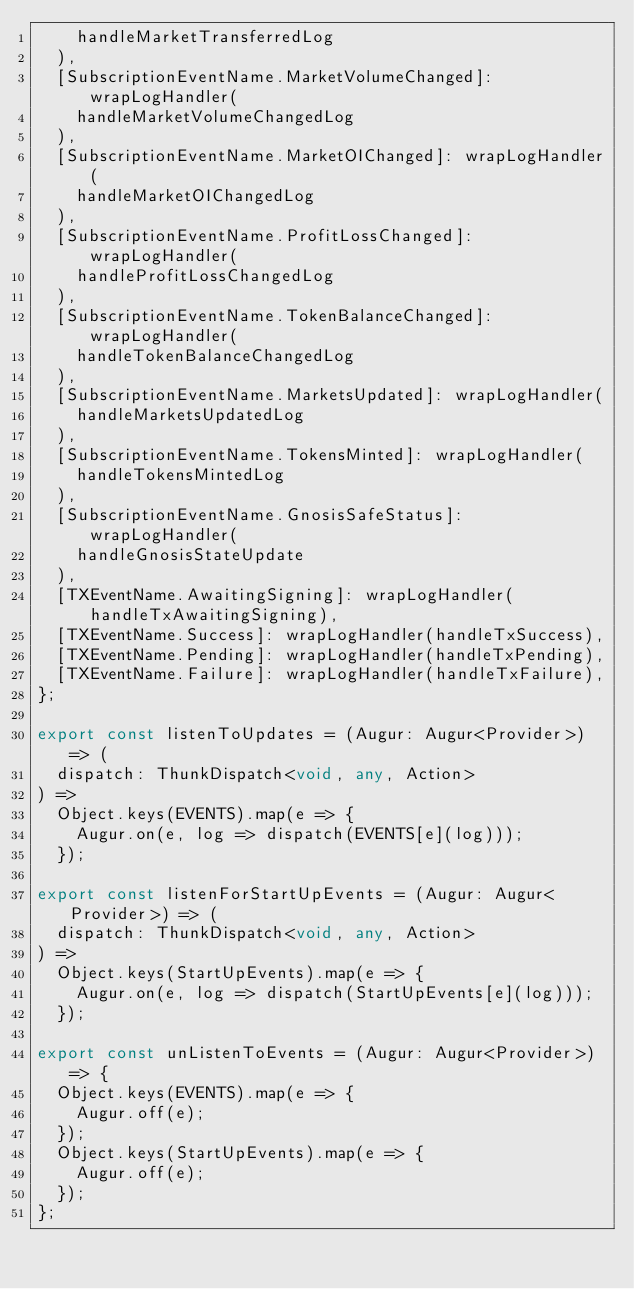<code> <loc_0><loc_0><loc_500><loc_500><_TypeScript_>    handleMarketTransferredLog
  ),
  [SubscriptionEventName.MarketVolumeChanged]: wrapLogHandler(
    handleMarketVolumeChangedLog
  ),
  [SubscriptionEventName.MarketOIChanged]: wrapLogHandler(
    handleMarketOIChangedLog
  ),
  [SubscriptionEventName.ProfitLossChanged]: wrapLogHandler(
    handleProfitLossChangedLog
  ),
  [SubscriptionEventName.TokenBalanceChanged]: wrapLogHandler(
    handleTokenBalanceChangedLog
  ),
  [SubscriptionEventName.MarketsUpdated]: wrapLogHandler(
    handleMarketsUpdatedLog
  ),
  [SubscriptionEventName.TokensMinted]: wrapLogHandler(
    handleTokensMintedLog
  ),
  [SubscriptionEventName.GnosisSafeStatus]: wrapLogHandler(
    handleGnosisStateUpdate
  ),
  [TXEventName.AwaitingSigning]: wrapLogHandler(handleTxAwaitingSigning),
  [TXEventName.Success]: wrapLogHandler(handleTxSuccess),
  [TXEventName.Pending]: wrapLogHandler(handleTxPending),
  [TXEventName.Failure]: wrapLogHandler(handleTxFailure),
};

export const listenToUpdates = (Augur: Augur<Provider>) => (
  dispatch: ThunkDispatch<void, any, Action>
) =>
  Object.keys(EVENTS).map(e => {
    Augur.on(e, log => dispatch(EVENTS[e](log)));
  });

export const listenForStartUpEvents = (Augur: Augur<Provider>) => (
  dispatch: ThunkDispatch<void, any, Action>
) =>
  Object.keys(StartUpEvents).map(e => {
    Augur.on(e, log => dispatch(StartUpEvents[e](log)));
  });

export const unListenToEvents = (Augur: Augur<Provider>) => {
  Object.keys(EVENTS).map(e => {
    Augur.off(e);
  });
  Object.keys(StartUpEvents).map(e => {
    Augur.off(e);
  });
};
</code> 